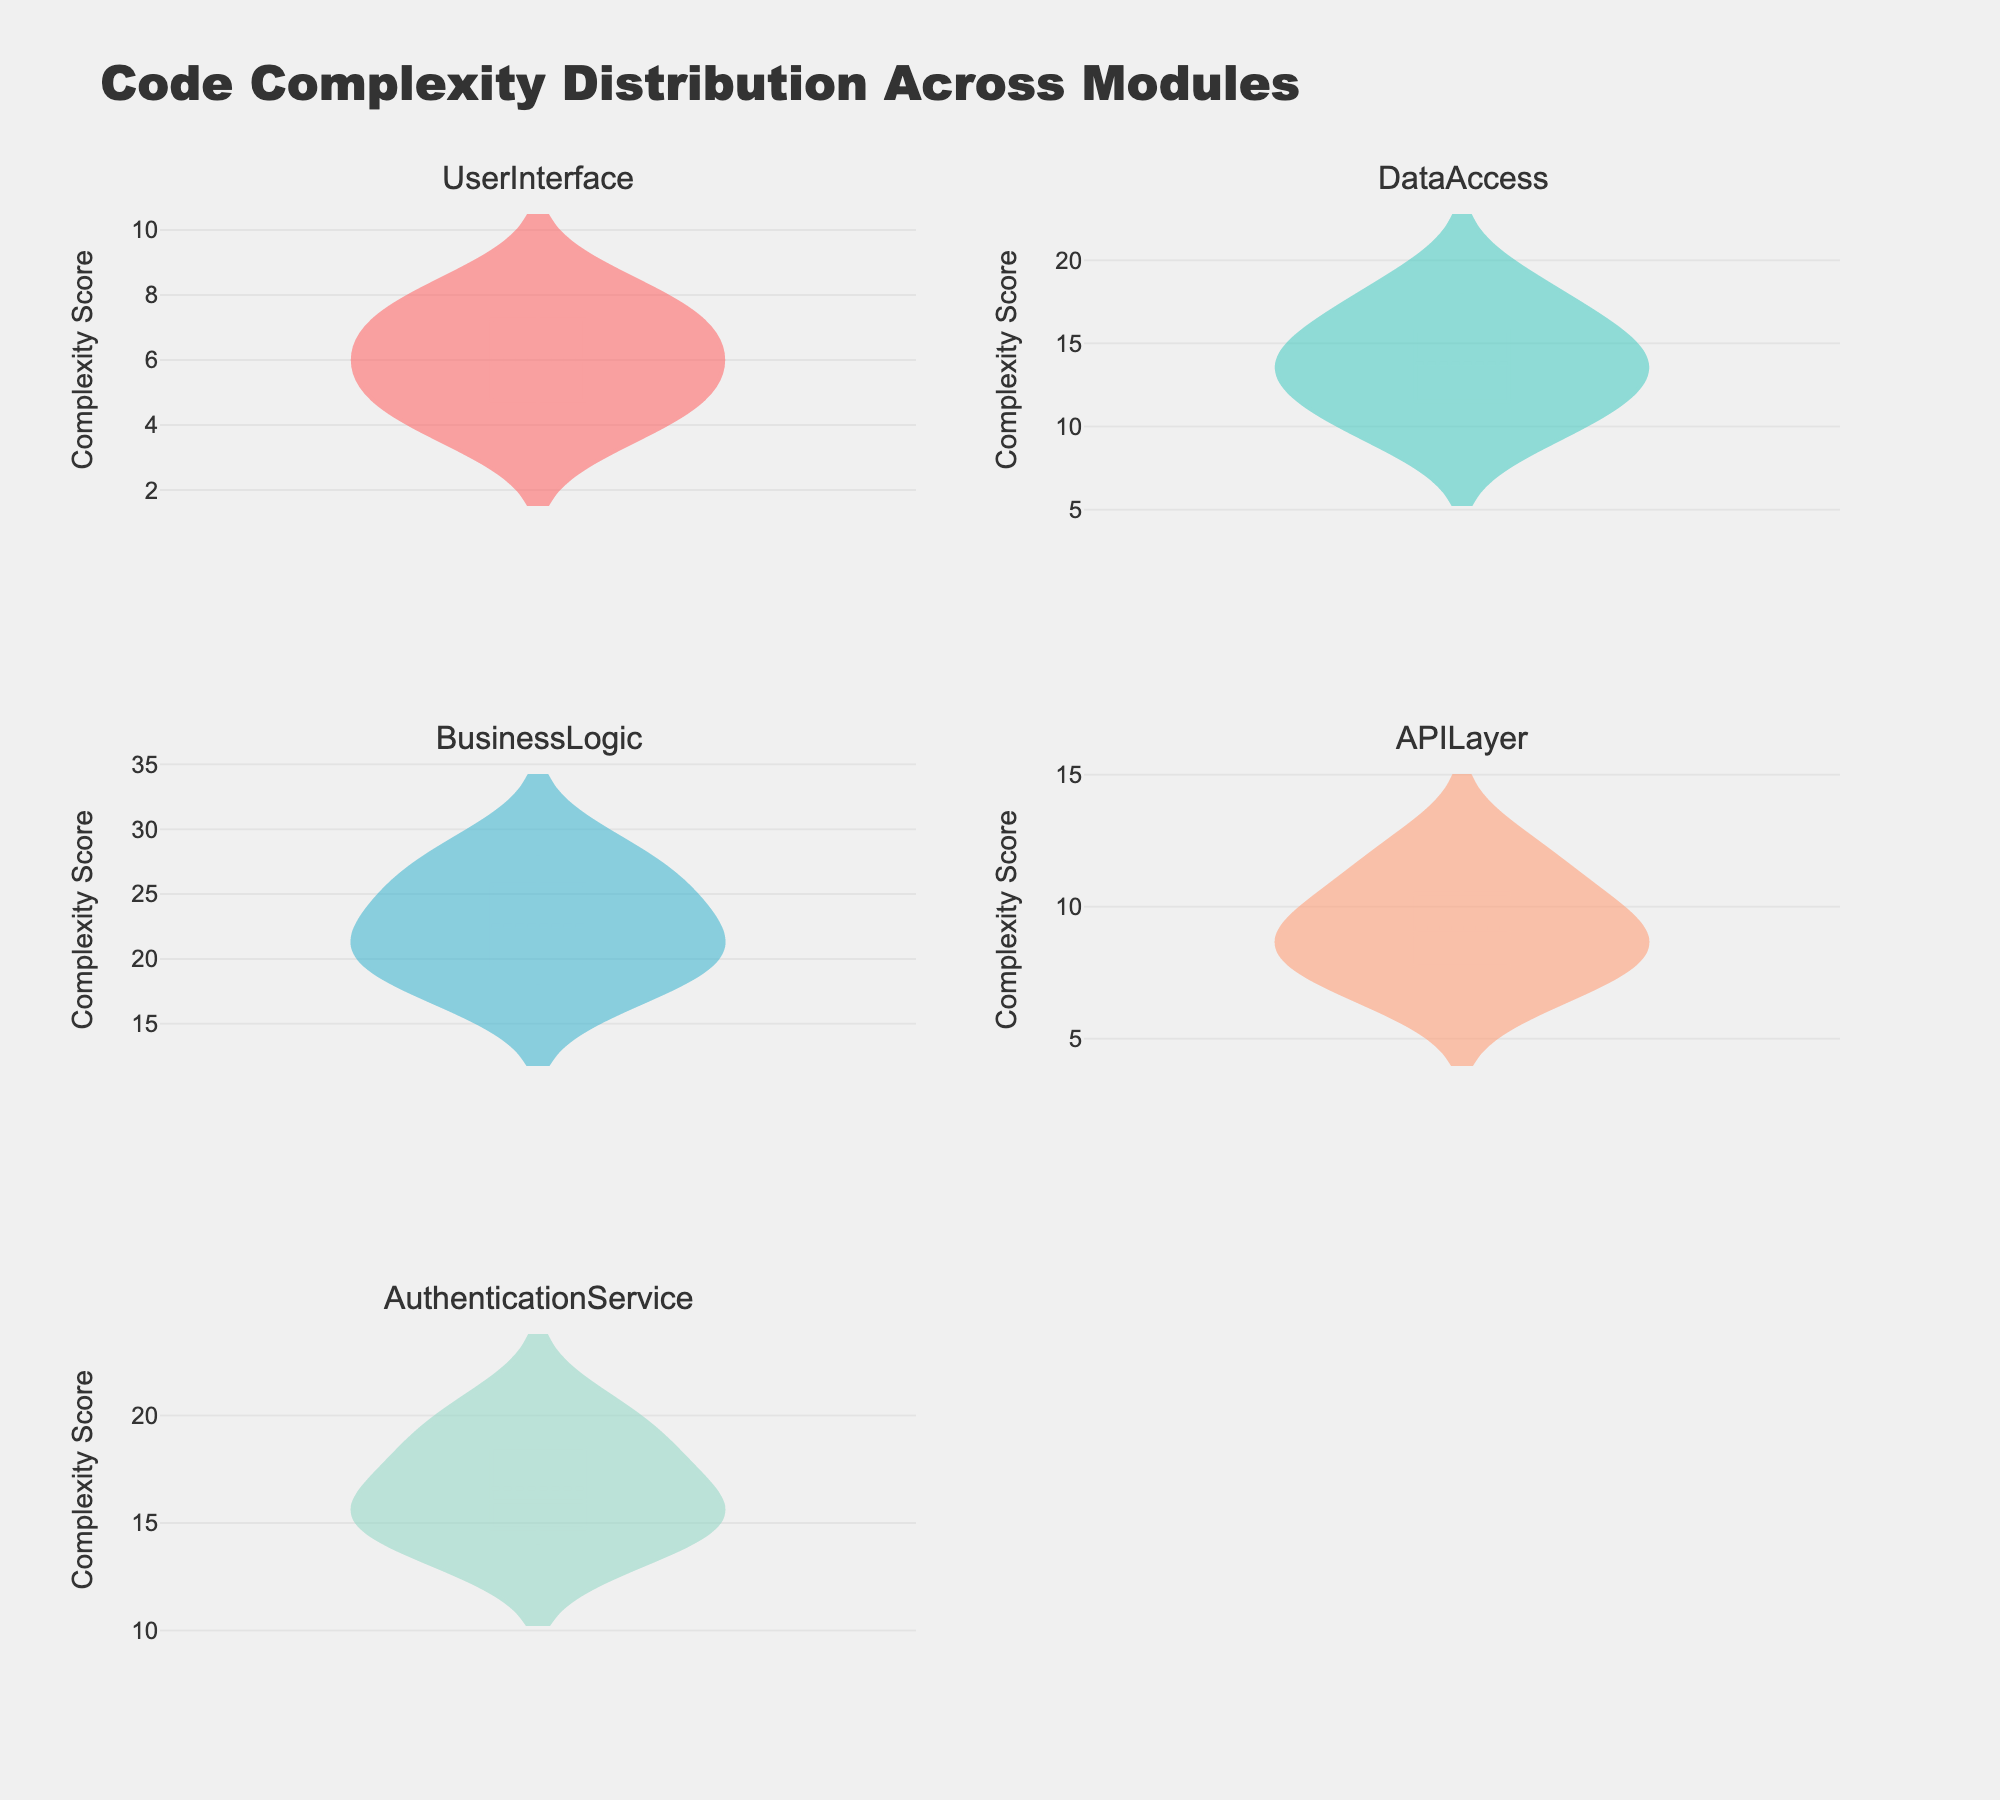what is the title of the figure? The title is located at the top of the figure and provides an overview of the data being presented. Here, the title is clearly stated as "Code Complexity Distribution Across Modules".
Answer: Code Complexity Distribution Across Modules Which module displays the widest spread in complexity scores? By examining the density plots for each module, we can determine which one has the widest range of complexity scores. The BusinessLogic module shows a spread from 18 to 28, which is the widest compared to other modules.
Answer: BusinessLogic What is the mean complexity score of the DataAccess module? The mean complexity score is indicated by the mean line in the density plot for the DataAccess module. We can visually estimate the mean from the figure, which appears to be at approximately 13.
Answer: Around 13 Which module has the lowest minimum complexity score? The minimum complexity score for each module can be found at the lower end of the density plots. The UserInterface module has the lowest minimum score, which is 4.
Answer: UserInterface Comparing the UserInterface and APILayer modules, which one has a higher mean complexity score? To determine this, we look at the mean lines on the density plots for both modules. The APILayer module has a higher mean complexity score compared to the UserInterface module.
Answer: APILayer What's the range of complexity scores for the AuthenticationService module? The range can be found by subtracting the minimum score from the maximum score on the density plot for the AuthenticationService module. The scores range from 14 to 20, giving a range of 6.
Answer: 6 Do any modules have overlapping complexity scores ranges? If so, which ones? By observing the density plots, we can note that UserInterface and APILayer modules have overlapping ranges, as both have complexity scores around 7-8.
Answer: UserInterface and APILayer Which module has the highest complexity score and what is that score? The highest complexity score can be identified by finding the peak on the density plots across all modules. The BusinessLogic module has the highest score, which is 28.
Answer: BusinessLogic, 28 Comparing the standard deviations (spread of scores) of the UserInterface and AuthenticationService modules, which one is larger? We observe the width and spread of the density plots for these modules. AuthenticationService has a larger spread compared to UserInterface, indicating a higher standard deviation.
Answer: AuthenticationService 